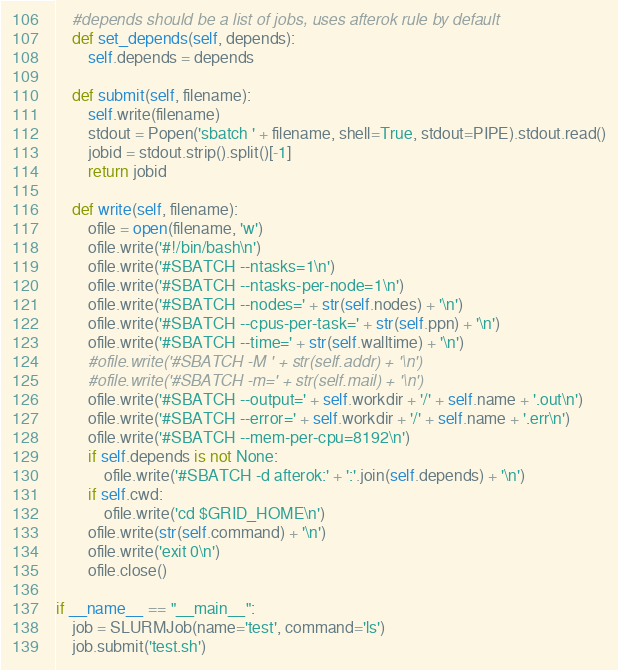Convert code to text. <code><loc_0><loc_0><loc_500><loc_500><_Python_>    #depends should be a list of jobs, uses afterok rule by default
    def set_depends(self, depends):
        self.depends = depends

    def submit(self, filename):
        self.write(filename)
        stdout = Popen('sbatch ' + filename, shell=True, stdout=PIPE).stdout.read()
        jobid = stdout.strip().split()[-1]
        return jobid

    def write(self, filename):
        ofile = open(filename, 'w')
        ofile.write('#!/bin/bash\n')
        ofile.write('#SBATCH --ntasks=1\n')
        ofile.write('#SBATCH --ntasks-per-node=1\n')
        ofile.write('#SBATCH --nodes=' + str(self.nodes) + '\n')
        ofile.write('#SBATCH --cpus-per-task=' + str(self.ppn) + '\n')
        ofile.write('#SBATCH --time=' + str(self.walltime) + '\n')
        #ofile.write('#SBATCH -M ' + str(self.addr) + '\n')
        #ofile.write('#SBATCH -m=' + str(self.mail) + '\n')
        ofile.write('#SBATCH --output=' + self.workdir + '/' + self.name + '.out\n')
        ofile.write('#SBATCH --error=' + self.workdir + '/' + self.name + '.err\n')
        ofile.write('#SBATCH --mem-per-cpu=8192\n')
        if self.depends is not None:
            ofile.write('#SBATCH -d afterok:' + ':'.join(self.depends) + '\n')
        if self.cwd:
            ofile.write('cd $GRID_HOME\n')
        ofile.write(str(self.command) + '\n')
        ofile.write('exit 0\n')
        ofile.close()

if __name__ == "__main__":
    job = SLURMJob(name='test', command='ls')
    job.submit('test.sh')
</code> 